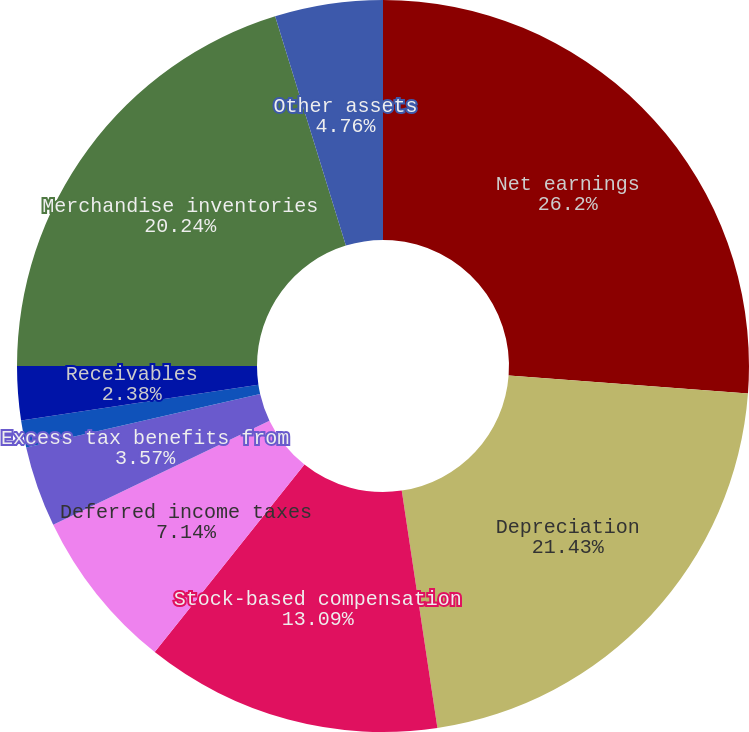<chart> <loc_0><loc_0><loc_500><loc_500><pie_chart><fcel>Net earnings<fcel>Depreciation<fcel>Stock-based compensation<fcel>Deferred income taxes<fcel>Minority interests<fcel>Excess tax benefits from<fcel>Other net<fcel>Receivables<fcel>Merchandise inventories<fcel>Other assets<nl><fcel>26.19%<fcel>21.42%<fcel>13.09%<fcel>7.14%<fcel>0.0%<fcel>3.57%<fcel>1.19%<fcel>2.38%<fcel>20.23%<fcel>4.76%<nl></chart> 